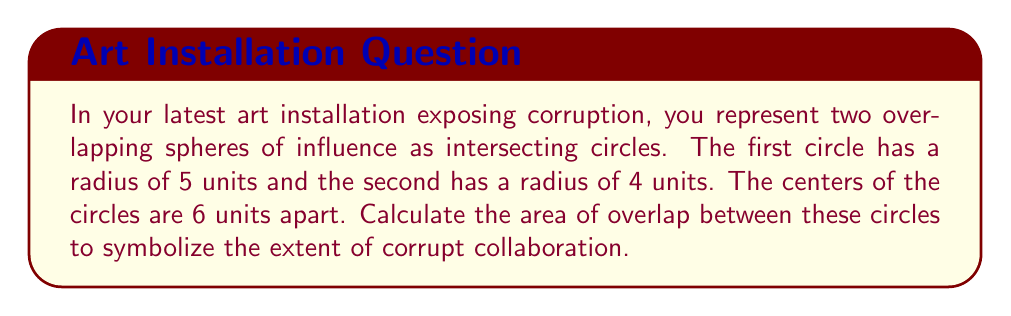Can you answer this question? Let's approach this step-by-step:

1) First, we need to calculate the distance from the center of each circle to the points where the circles intersect. Let's call this distance $a$ for the larger circle and $b$ for the smaller circle.

2) We can use the Pythagorean theorem to set up an equation:

   $a^2 + h^2 = 5^2$ and $b^2 + h^2 = 4^2$, where $h$ is half the length of the common chord.

3) We also know that $a + b = 6$ (the distance between centers).

4) From step 2, we can derive: $a^2 - b^2 = 5^2 - 4^2 = 9$

5) Using the equation from step 3, we can substitute $b = 6 - a$:
   $a^2 - (6-a)^2 = 9$
   $a^2 - 36 + 12a - a^2 = 9$
   $12a = 45$
   $a = 3.75$

6) Now we can find $b = 6 - 3.75 = 2.25$

7) The area of overlap is given by the formula:
   $A = r_1^2 \arccos(\frac{a}{r_1}) + r_2^2 \arccos(\frac{b}{r_2}) - \frac{1}{2}\sqrt{(-d+r_1+r_2)(d+r_1-r_2)(d-r_1+r_2)(d+r_1+r_2)}$

   Where $d$ is the distance between centers, and $r_1$ and $r_2$ are the radii.

8) Plugging in our values:
   $A = 5^2 \arccos(\frac{3.75}{5}) + 4^2 \arccos(\frac{2.25}{4}) - \frac{1}{2}\sqrt{(-6+5+4)(6+5-4)(6-5+4)(6+5+4)}$

9) Calculating this gives us approximately 16.02 square units.

[asy]
unitsize(15);
draw(circle((0,0),5));
draw(circle((6,0),4));
label("5",(2.5,0),N);
label("4",(4.5,0),N);
label("6",(3,0),S);
[/asy]
Answer: $16.02$ square units 